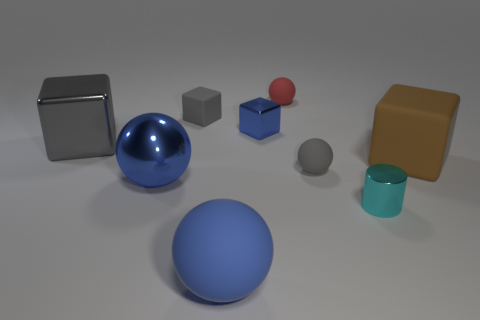Add 1 blue things. How many objects exist? 10 Subtract all cylinders. How many objects are left? 8 Add 5 big blue matte objects. How many big blue matte objects exist? 6 Subtract 1 brown blocks. How many objects are left? 8 Subtract all brown cubes. Subtract all shiny balls. How many objects are left? 7 Add 4 rubber blocks. How many rubber blocks are left? 6 